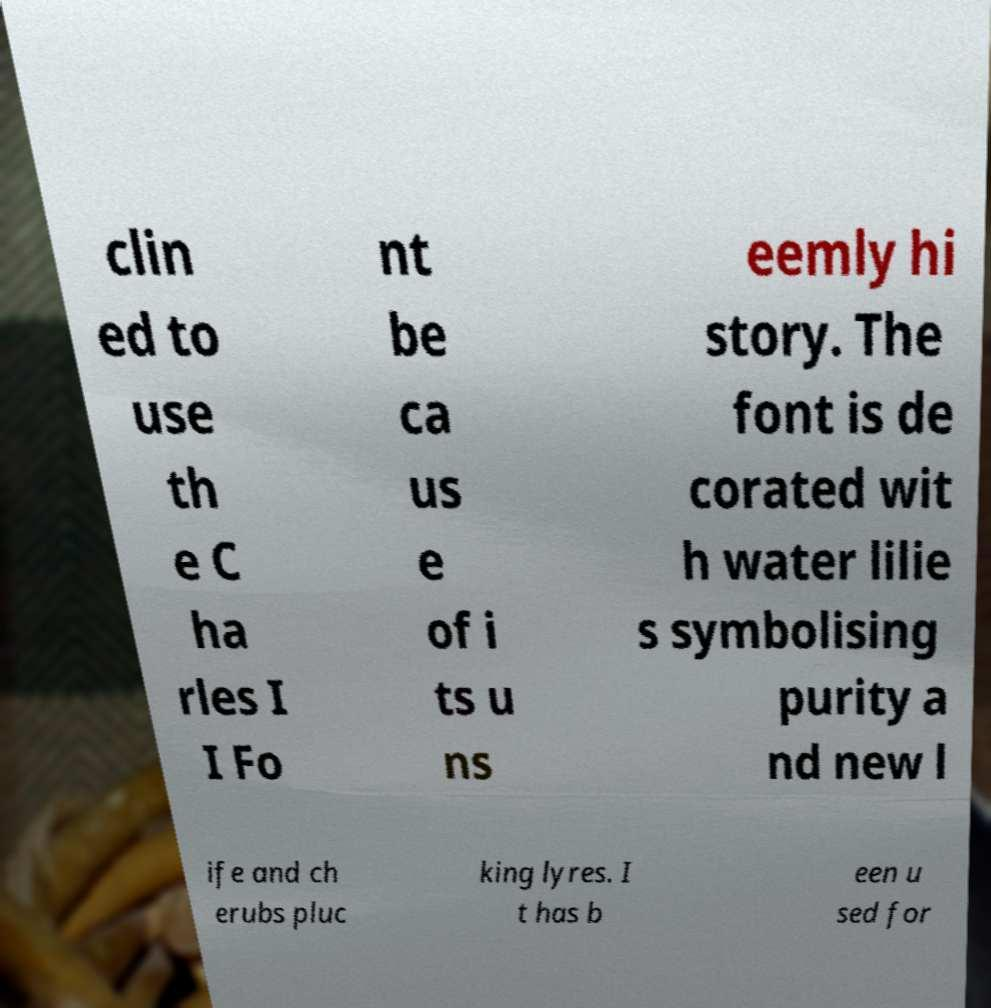Please identify and transcribe the text found in this image. clin ed to use th e C ha rles I I Fo nt be ca us e of i ts u ns eemly hi story. The font is de corated wit h water lilie s symbolising purity a nd new l ife and ch erubs pluc king lyres. I t has b een u sed for 